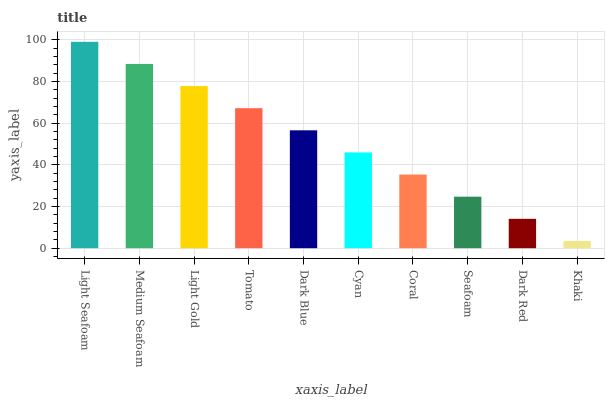Is Khaki the minimum?
Answer yes or no. Yes. Is Light Seafoam the maximum?
Answer yes or no. Yes. Is Medium Seafoam the minimum?
Answer yes or no. No. Is Medium Seafoam the maximum?
Answer yes or no. No. Is Light Seafoam greater than Medium Seafoam?
Answer yes or no. Yes. Is Medium Seafoam less than Light Seafoam?
Answer yes or no. Yes. Is Medium Seafoam greater than Light Seafoam?
Answer yes or no. No. Is Light Seafoam less than Medium Seafoam?
Answer yes or no. No. Is Dark Blue the high median?
Answer yes or no. Yes. Is Cyan the low median?
Answer yes or no. Yes. Is Medium Seafoam the high median?
Answer yes or no. No. Is Dark Blue the low median?
Answer yes or no. No. 